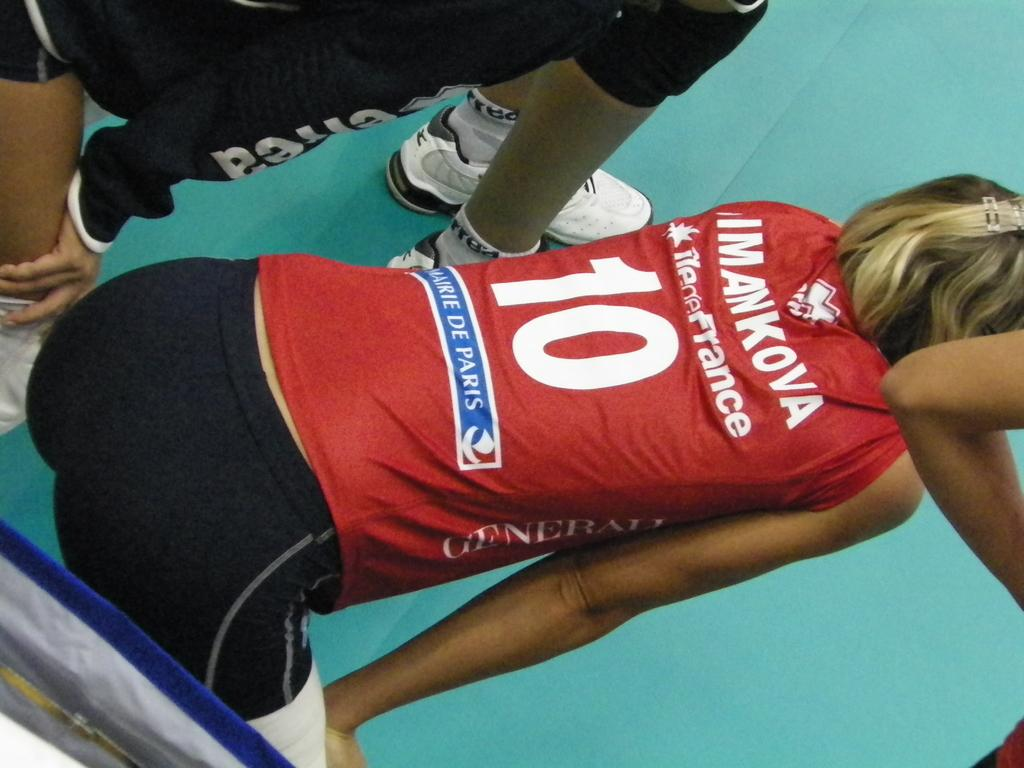Provide a one-sentence caption for the provided image. Mankova wears a red jersey with the number 10. 